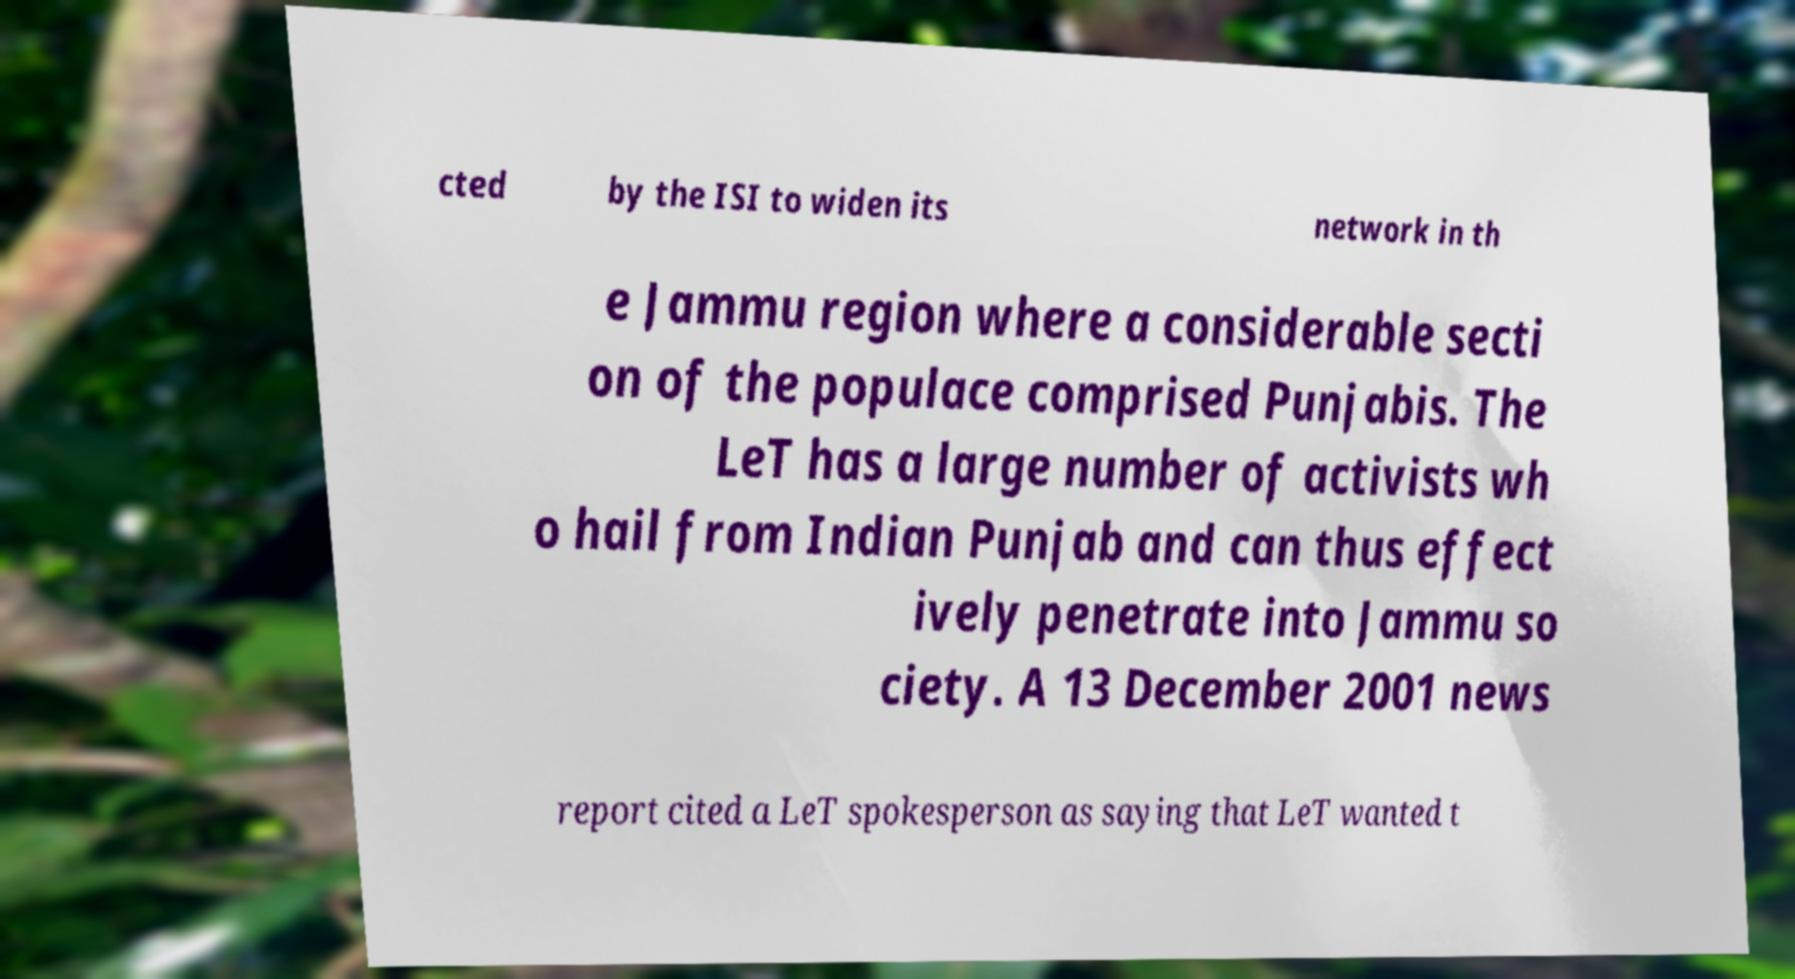What messages or text are displayed in this image? I need them in a readable, typed format. cted by the ISI to widen its network in th e Jammu region where a considerable secti on of the populace comprised Punjabis. The LeT has a large number of activists wh o hail from Indian Punjab and can thus effect ively penetrate into Jammu so ciety. A 13 December 2001 news report cited a LeT spokesperson as saying that LeT wanted t 